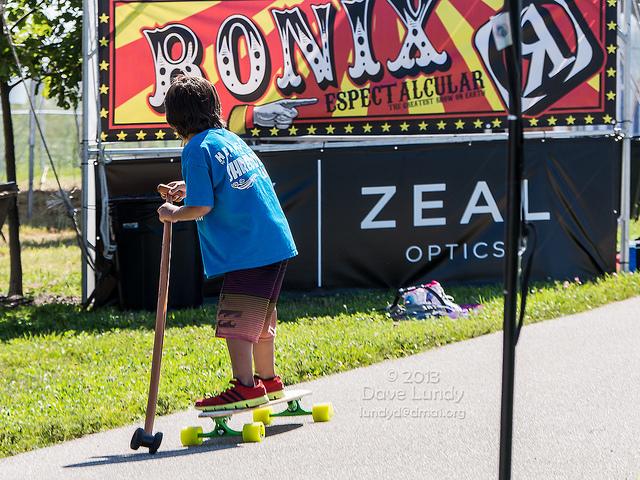What year is stamped on the photo?
Be succinct. 2013. What is laying in the grass?
Keep it brief. Backpack. Is the boy looking at the advertisement?
Answer briefly. Yes. 